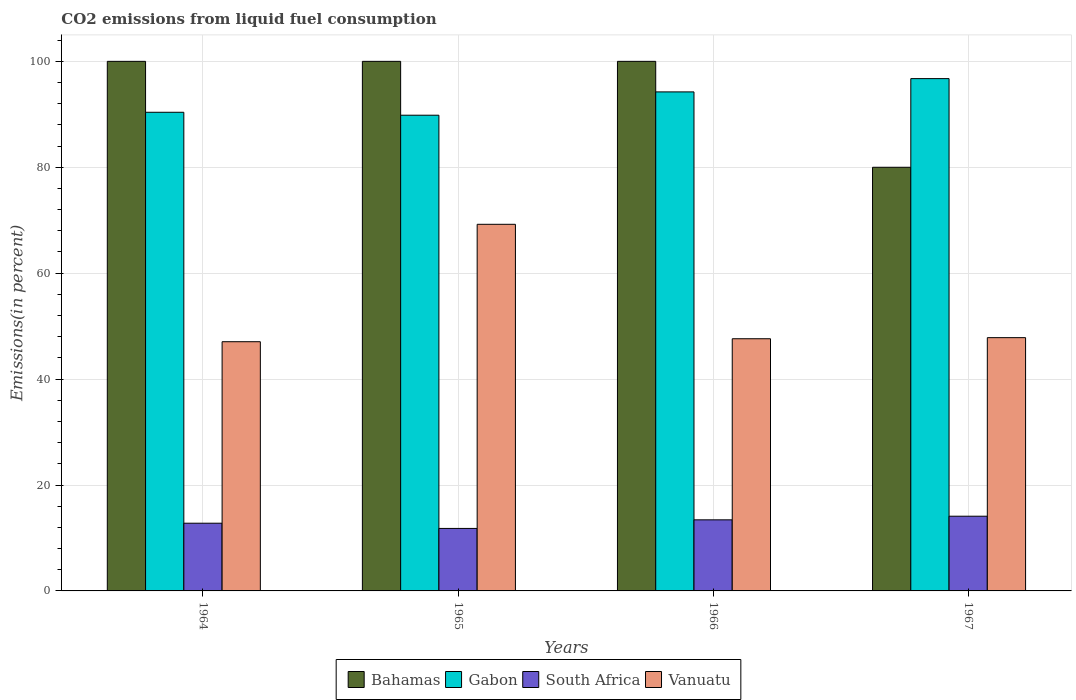How many groups of bars are there?
Your answer should be compact. 4. Are the number of bars on each tick of the X-axis equal?
Offer a very short reply. Yes. How many bars are there on the 3rd tick from the left?
Your answer should be very brief. 4. What is the label of the 4th group of bars from the left?
Provide a short and direct response. 1967. What is the total CO2 emitted in Gabon in 1966?
Offer a terse response. 94.23. Across all years, what is the maximum total CO2 emitted in Bahamas?
Ensure brevity in your answer.  100. Across all years, what is the minimum total CO2 emitted in South Africa?
Keep it short and to the point. 11.8. In which year was the total CO2 emitted in Vanuatu maximum?
Your answer should be compact. 1965. In which year was the total CO2 emitted in Gabon minimum?
Give a very brief answer. 1965. What is the total total CO2 emitted in Vanuatu in the graph?
Your answer should be compact. 211.73. What is the difference between the total CO2 emitted in Vanuatu in 1965 and that in 1966?
Make the answer very short. 21.61. What is the difference between the total CO2 emitted in South Africa in 1965 and the total CO2 emitted in Vanuatu in 1966?
Your answer should be compact. -35.82. What is the average total CO2 emitted in South Africa per year?
Provide a succinct answer. 13.03. In the year 1964, what is the difference between the total CO2 emitted in Vanuatu and total CO2 emitted in Gabon?
Your response must be concise. -43.33. What is the ratio of the total CO2 emitted in South Africa in 1966 to that in 1967?
Your response must be concise. 0.95. Is the total CO2 emitted in South Africa in 1964 less than that in 1966?
Offer a very short reply. Yes. What is the difference between the highest and the second highest total CO2 emitted in Bahamas?
Make the answer very short. 0. What is the difference between the highest and the lowest total CO2 emitted in Gabon?
Offer a terse response. 6.91. In how many years, is the total CO2 emitted in Vanuatu greater than the average total CO2 emitted in Vanuatu taken over all years?
Ensure brevity in your answer.  1. Is the sum of the total CO2 emitted in Vanuatu in 1964 and 1966 greater than the maximum total CO2 emitted in Bahamas across all years?
Offer a terse response. No. Is it the case that in every year, the sum of the total CO2 emitted in South Africa and total CO2 emitted in Bahamas is greater than the sum of total CO2 emitted in Vanuatu and total CO2 emitted in Gabon?
Make the answer very short. No. What does the 3rd bar from the left in 1966 represents?
Offer a very short reply. South Africa. What does the 1st bar from the right in 1967 represents?
Your response must be concise. Vanuatu. Are all the bars in the graph horizontal?
Offer a terse response. No. How many years are there in the graph?
Your response must be concise. 4. Are the values on the major ticks of Y-axis written in scientific E-notation?
Give a very brief answer. No. Does the graph contain any zero values?
Make the answer very short. No. Does the graph contain grids?
Give a very brief answer. Yes. How many legend labels are there?
Make the answer very short. 4. How are the legend labels stacked?
Your answer should be compact. Horizontal. What is the title of the graph?
Ensure brevity in your answer.  CO2 emissions from liquid fuel consumption. What is the label or title of the Y-axis?
Offer a very short reply. Emissions(in percent). What is the Emissions(in percent) in Bahamas in 1964?
Keep it short and to the point. 100. What is the Emissions(in percent) of Gabon in 1964?
Ensure brevity in your answer.  90.38. What is the Emissions(in percent) of South Africa in 1964?
Provide a succinct answer. 12.79. What is the Emissions(in percent) of Vanuatu in 1964?
Give a very brief answer. 47.06. What is the Emissions(in percent) of Gabon in 1965?
Make the answer very short. 89.83. What is the Emissions(in percent) of South Africa in 1965?
Offer a very short reply. 11.8. What is the Emissions(in percent) of Vanuatu in 1965?
Make the answer very short. 69.23. What is the Emissions(in percent) of Gabon in 1966?
Offer a terse response. 94.23. What is the Emissions(in percent) of South Africa in 1966?
Provide a succinct answer. 13.42. What is the Emissions(in percent) in Vanuatu in 1966?
Your answer should be compact. 47.62. What is the Emissions(in percent) in Gabon in 1967?
Offer a very short reply. 96.74. What is the Emissions(in percent) of South Africa in 1967?
Offer a terse response. 14.11. What is the Emissions(in percent) of Vanuatu in 1967?
Keep it short and to the point. 47.83. Across all years, what is the maximum Emissions(in percent) of Gabon?
Your answer should be very brief. 96.74. Across all years, what is the maximum Emissions(in percent) of South Africa?
Offer a terse response. 14.11. Across all years, what is the maximum Emissions(in percent) of Vanuatu?
Make the answer very short. 69.23. Across all years, what is the minimum Emissions(in percent) in Gabon?
Make the answer very short. 89.83. Across all years, what is the minimum Emissions(in percent) in South Africa?
Your response must be concise. 11.8. Across all years, what is the minimum Emissions(in percent) in Vanuatu?
Your answer should be compact. 47.06. What is the total Emissions(in percent) of Bahamas in the graph?
Offer a very short reply. 380. What is the total Emissions(in percent) in Gabon in the graph?
Offer a very short reply. 371.19. What is the total Emissions(in percent) in South Africa in the graph?
Offer a terse response. 52.12. What is the total Emissions(in percent) in Vanuatu in the graph?
Keep it short and to the point. 211.73. What is the difference between the Emissions(in percent) in Gabon in 1964 and that in 1965?
Your answer should be compact. 0.55. What is the difference between the Emissions(in percent) in South Africa in 1964 and that in 1965?
Provide a short and direct response. 0.99. What is the difference between the Emissions(in percent) in Vanuatu in 1964 and that in 1965?
Offer a very short reply. -22.17. What is the difference between the Emissions(in percent) in Gabon in 1964 and that in 1966?
Your answer should be compact. -3.85. What is the difference between the Emissions(in percent) in South Africa in 1964 and that in 1966?
Ensure brevity in your answer.  -0.64. What is the difference between the Emissions(in percent) of Vanuatu in 1964 and that in 1966?
Provide a succinct answer. -0.56. What is the difference between the Emissions(in percent) in Bahamas in 1964 and that in 1967?
Your answer should be compact. 20. What is the difference between the Emissions(in percent) in Gabon in 1964 and that in 1967?
Offer a terse response. -6.35. What is the difference between the Emissions(in percent) of South Africa in 1964 and that in 1967?
Offer a terse response. -1.32. What is the difference between the Emissions(in percent) in Vanuatu in 1964 and that in 1967?
Keep it short and to the point. -0.77. What is the difference between the Emissions(in percent) in Bahamas in 1965 and that in 1966?
Your response must be concise. 0. What is the difference between the Emissions(in percent) in Gabon in 1965 and that in 1966?
Provide a short and direct response. -4.4. What is the difference between the Emissions(in percent) of South Africa in 1965 and that in 1966?
Keep it short and to the point. -1.63. What is the difference between the Emissions(in percent) in Vanuatu in 1965 and that in 1966?
Ensure brevity in your answer.  21.61. What is the difference between the Emissions(in percent) of Gabon in 1965 and that in 1967?
Provide a succinct answer. -6.91. What is the difference between the Emissions(in percent) in South Africa in 1965 and that in 1967?
Ensure brevity in your answer.  -2.31. What is the difference between the Emissions(in percent) of Vanuatu in 1965 and that in 1967?
Your response must be concise. 21.4. What is the difference between the Emissions(in percent) of Gabon in 1966 and that in 1967?
Your answer should be very brief. -2.51. What is the difference between the Emissions(in percent) of South Africa in 1966 and that in 1967?
Your response must be concise. -0.68. What is the difference between the Emissions(in percent) in Vanuatu in 1966 and that in 1967?
Ensure brevity in your answer.  -0.21. What is the difference between the Emissions(in percent) in Bahamas in 1964 and the Emissions(in percent) in Gabon in 1965?
Keep it short and to the point. 10.17. What is the difference between the Emissions(in percent) in Bahamas in 1964 and the Emissions(in percent) in South Africa in 1965?
Your answer should be very brief. 88.2. What is the difference between the Emissions(in percent) of Bahamas in 1964 and the Emissions(in percent) of Vanuatu in 1965?
Offer a terse response. 30.77. What is the difference between the Emissions(in percent) in Gabon in 1964 and the Emissions(in percent) in South Africa in 1965?
Your answer should be very brief. 78.59. What is the difference between the Emissions(in percent) in Gabon in 1964 and the Emissions(in percent) in Vanuatu in 1965?
Give a very brief answer. 21.15. What is the difference between the Emissions(in percent) in South Africa in 1964 and the Emissions(in percent) in Vanuatu in 1965?
Provide a succinct answer. -56.45. What is the difference between the Emissions(in percent) in Bahamas in 1964 and the Emissions(in percent) in Gabon in 1966?
Keep it short and to the point. 5.77. What is the difference between the Emissions(in percent) of Bahamas in 1964 and the Emissions(in percent) of South Africa in 1966?
Offer a terse response. 86.58. What is the difference between the Emissions(in percent) in Bahamas in 1964 and the Emissions(in percent) in Vanuatu in 1966?
Your response must be concise. 52.38. What is the difference between the Emissions(in percent) of Gabon in 1964 and the Emissions(in percent) of South Africa in 1966?
Offer a very short reply. 76.96. What is the difference between the Emissions(in percent) in Gabon in 1964 and the Emissions(in percent) in Vanuatu in 1966?
Your response must be concise. 42.77. What is the difference between the Emissions(in percent) of South Africa in 1964 and the Emissions(in percent) of Vanuatu in 1966?
Your answer should be very brief. -34.83. What is the difference between the Emissions(in percent) of Bahamas in 1964 and the Emissions(in percent) of Gabon in 1967?
Provide a short and direct response. 3.26. What is the difference between the Emissions(in percent) of Bahamas in 1964 and the Emissions(in percent) of South Africa in 1967?
Provide a succinct answer. 85.89. What is the difference between the Emissions(in percent) of Bahamas in 1964 and the Emissions(in percent) of Vanuatu in 1967?
Keep it short and to the point. 52.17. What is the difference between the Emissions(in percent) in Gabon in 1964 and the Emissions(in percent) in South Africa in 1967?
Your answer should be compact. 76.28. What is the difference between the Emissions(in percent) of Gabon in 1964 and the Emissions(in percent) of Vanuatu in 1967?
Offer a terse response. 42.56. What is the difference between the Emissions(in percent) of South Africa in 1964 and the Emissions(in percent) of Vanuatu in 1967?
Your answer should be compact. -35.04. What is the difference between the Emissions(in percent) in Bahamas in 1965 and the Emissions(in percent) in Gabon in 1966?
Your response must be concise. 5.77. What is the difference between the Emissions(in percent) of Bahamas in 1965 and the Emissions(in percent) of South Africa in 1966?
Make the answer very short. 86.58. What is the difference between the Emissions(in percent) in Bahamas in 1965 and the Emissions(in percent) in Vanuatu in 1966?
Offer a very short reply. 52.38. What is the difference between the Emissions(in percent) in Gabon in 1965 and the Emissions(in percent) in South Africa in 1966?
Provide a succinct answer. 76.41. What is the difference between the Emissions(in percent) in Gabon in 1965 and the Emissions(in percent) in Vanuatu in 1966?
Ensure brevity in your answer.  42.21. What is the difference between the Emissions(in percent) in South Africa in 1965 and the Emissions(in percent) in Vanuatu in 1966?
Your answer should be very brief. -35.82. What is the difference between the Emissions(in percent) of Bahamas in 1965 and the Emissions(in percent) of Gabon in 1967?
Give a very brief answer. 3.26. What is the difference between the Emissions(in percent) of Bahamas in 1965 and the Emissions(in percent) of South Africa in 1967?
Give a very brief answer. 85.89. What is the difference between the Emissions(in percent) in Bahamas in 1965 and the Emissions(in percent) in Vanuatu in 1967?
Keep it short and to the point. 52.17. What is the difference between the Emissions(in percent) of Gabon in 1965 and the Emissions(in percent) of South Africa in 1967?
Provide a short and direct response. 75.72. What is the difference between the Emissions(in percent) of Gabon in 1965 and the Emissions(in percent) of Vanuatu in 1967?
Keep it short and to the point. 42. What is the difference between the Emissions(in percent) in South Africa in 1965 and the Emissions(in percent) in Vanuatu in 1967?
Your answer should be very brief. -36.03. What is the difference between the Emissions(in percent) of Bahamas in 1966 and the Emissions(in percent) of Gabon in 1967?
Give a very brief answer. 3.26. What is the difference between the Emissions(in percent) in Bahamas in 1966 and the Emissions(in percent) in South Africa in 1967?
Provide a short and direct response. 85.89. What is the difference between the Emissions(in percent) in Bahamas in 1966 and the Emissions(in percent) in Vanuatu in 1967?
Give a very brief answer. 52.17. What is the difference between the Emissions(in percent) in Gabon in 1966 and the Emissions(in percent) in South Africa in 1967?
Make the answer very short. 80.12. What is the difference between the Emissions(in percent) in Gabon in 1966 and the Emissions(in percent) in Vanuatu in 1967?
Your answer should be compact. 46.4. What is the difference between the Emissions(in percent) of South Africa in 1966 and the Emissions(in percent) of Vanuatu in 1967?
Your answer should be very brief. -34.4. What is the average Emissions(in percent) of Gabon per year?
Keep it short and to the point. 92.8. What is the average Emissions(in percent) of South Africa per year?
Provide a short and direct response. 13.03. What is the average Emissions(in percent) of Vanuatu per year?
Your answer should be very brief. 52.93. In the year 1964, what is the difference between the Emissions(in percent) of Bahamas and Emissions(in percent) of Gabon?
Your answer should be compact. 9.62. In the year 1964, what is the difference between the Emissions(in percent) of Bahamas and Emissions(in percent) of South Africa?
Ensure brevity in your answer.  87.21. In the year 1964, what is the difference between the Emissions(in percent) in Bahamas and Emissions(in percent) in Vanuatu?
Offer a terse response. 52.94. In the year 1964, what is the difference between the Emissions(in percent) in Gabon and Emissions(in percent) in South Africa?
Give a very brief answer. 77.6. In the year 1964, what is the difference between the Emissions(in percent) in Gabon and Emissions(in percent) in Vanuatu?
Give a very brief answer. 43.33. In the year 1964, what is the difference between the Emissions(in percent) in South Africa and Emissions(in percent) in Vanuatu?
Provide a short and direct response. -34.27. In the year 1965, what is the difference between the Emissions(in percent) in Bahamas and Emissions(in percent) in Gabon?
Your answer should be very brief. 10.17. In the year 1965, what is the difference between the Emissions(in percent) of Bahamas and Emissions(in percent) of South Africa?
Your response must be concise. 88.2. In the year 1965, what is the difference between the Emissions(in percent) in Bahamas and Emissions(in percent) in Vanuatu?
Give a very brief answer. 30.77. In the year 1965, what is the difference between the Emissions(in percent) in Gabon and Emissions(in percent) in South Africa?
Ensure brevity in your answer.  78.03. In the year 1965, what is the difference between the Emissions(in percent) in Gabon and Emissions(in percent) in Vanuatu?
Ensure brevity in your answer.  20.6. In the year 1965, what is the difference between the Emissions(in percent) of South Africa and Emissions(in percent) of Vanuatu?
Provide a succinct answer. -57.43. In the year 1966, what is the difference between the Emissions(in percent) in Bahamas and Emissions(in percent) in Gabon?
Offer a terse response. 5.77. In the year 1966, what is the difference between the Emissions(in percent) of Bahamas and Emissions(in percent) of South Africa?
Make the answer very short. 86.58. In the year 1966, what is the difference between the Emissions(in percent) in Bahamas and Emissions(in percent) in Vanuatu?
Make the answer very short. 52.38. In the year 1966, what is the difference between the Emissions(in percent) in Gabon and Emissions(in percent) in South Africa?
Offer a very short reply. 80.81. In the year 1966, what is the difference between the Emissions(in percent) in Gabon and Emissions(in percent) in Vanuatu?
Offer a terse response. 46.61. In the year 1966, what is the difference between the Emissions(in percent) of South Africa and Emissions(in percent) of Vanuatu?
Your answer should be compact. -34.19. In the year 1967, what is the difference between the Emissions(in percent) of Bahamas and Emissions(in percent) of Gabon?
Offer a very short reply. -16.74. In the year 1967, what is the difference between the Emissions(in percent) in Bahamas and Emissions(in percent) in South Africa?
Provide a short and direct response. 65.89. In the year 1967, what is the difference between the Emissions(in percent) in Bahamas and Emissions(in percent) in Vanuatu?
Make the answer very short. 32.17. In the year 1967, what is the difference between the Emissions(in percent) of Gabon and Emissions(in percent) of South Africa?
Give a very brief answer. 82.63. In the year 1967, what is the difference between the Emissions(in percent) in Gabon and Emissions(in percent) in Vanuatu?
Keep it short and to the point. 48.91. In the year 1967, what is the difference between the Emissions(in percent) of South Africa and Emissions(in percent) of Vanuatu?
Make the answer very short. -33.72. What is the ratio of the Emissions(in percent) in Gabon in 1964 to that in 1965?
Make the answer very short. 1.01. What is the ratio of the Emissions(in percent) in South Africa in 1964 to that in 1965?
Keep it short and to the point. 1.08. What is the ratio of the Emissions(in percent) in Vanuatu in 1964 to that in 1965?
Keep it short and to the point. 0.68. What is the ratio of the Emissions(in percent) in Gabon in 1964 to that in 1966?
Make the answer very short. 0.96. What is the ratio of the Emissions(in percent) of South Africa in 1964 to that in 1966?
Provide a short and direct response. 0.95. What is the ratio of the Emissions(in percent) of Vanuatu in 1964 to that in 1966?
Offer a very short reply. 0.99. What is the ratio of the Emissions(in percent) of Bahamas in 1964 to that in 1967?
Provide a short and direct response. 1.25. What is the ratio of the Emissions(in percent) in Gabon in 1964 to that in 1967?
Your response must be concise. 0.93. What is the ratio of the Emissions(in percent) of South Africa in 1964 to that in 1967?
Ensure brevity in your answer.  0.91. What is the ratio of the Emissions(in percent) in Gabon in 1965 to that in 1966?
Offer a very short reply. 0.95. What is the ratio of the Emissions(in percent) in South Africa in 1965 to that in 1966?
Make the answer very short. 0.88. What is the ratio of the Emissions(in percent) of Vanuatu in 1965 to that in 1966?
Provide a succinct answer. 1.45. What is the ratio of the Emissions(in percent) of Gabon in 1965 to that in 1967?
Make the answer very short. 0.93. What is the ratio of the Emissions(in percent) in South Africa in 1965 to that in 1967?
Your answer should be compact. 0.84. What is the ratio of the Emissions(in percent) of Vanuatu in 1965 to that in 1967?
Your answer should be very brief. 1.45. What is the ratio of the Emissions(in percent) of Gabon in 1966 to that in 1967?
Give a very brief answer. 0.97. What is the ratio of the Emissions(in percent) of South Africa in 1966 to that in 1967?
Provide a succinct answer. 0.95. What is the ratio of the Emissions(in percent) of Vanuatu in 1966 to that in 1967?
Provide a short and direct response. 1. What is the difference between the highest and the second highest Emissions(in percent) of Gabon?
Offer a very short reply. 2.51. What is the difference between the highest and the second highest Emissions(in percent) of South Africa?
Offer a very short reply. 0.68. What is the difference between the highest and the second highest Emissions(in percent) in Vanuatu?
Your answer should be compact. 21.4. What is the difference between the highest and the lowest Emissions(in percent) of Gabon?
Offer a terse response. 6.91. What is the difference between the highest and the lowest Emissions(in percent) of South Africa?
Offer a very short reply. 2.31. What is the difference between the highest and the lowest Emissions(in percent) in Vanuatu?
Make the answer very short. 22.17. 